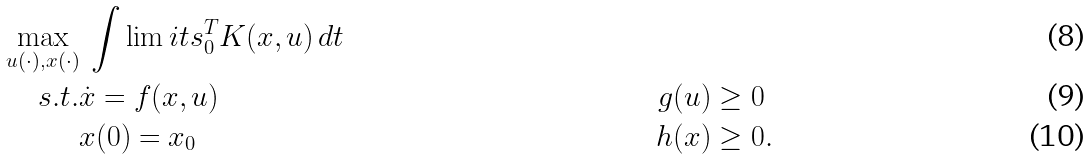Convert formula to latex. <formula><loc_0><loc_0><loc_500><loc_500>\max _ { u ( \cdot ) , x ( \cdot ) } & \ \int \lim i t s _ { 0 } ^ { T } K ( x , u ) \, d t \\ s . t . & \dot { x } = f ( x , u ) & g ( u ) & \geq 0 \\ & x ( 0 ) = x _ { 0 } & h ( x ) & \geq 0 .</formula> 